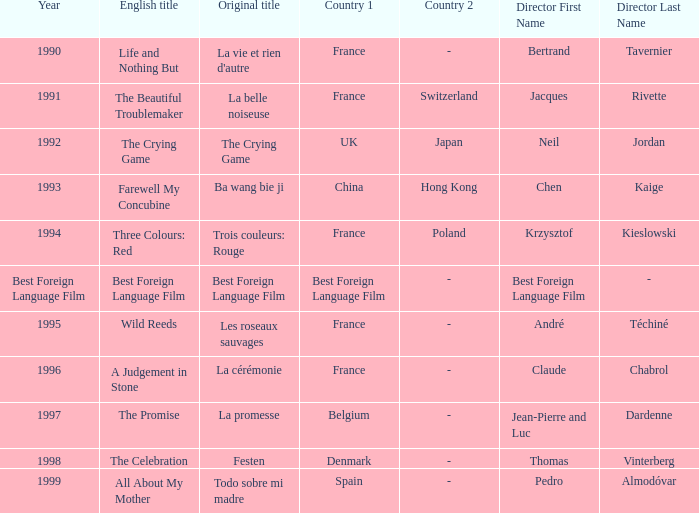Which Year has the Orginal title of La Cérémonie? 1996.0. 